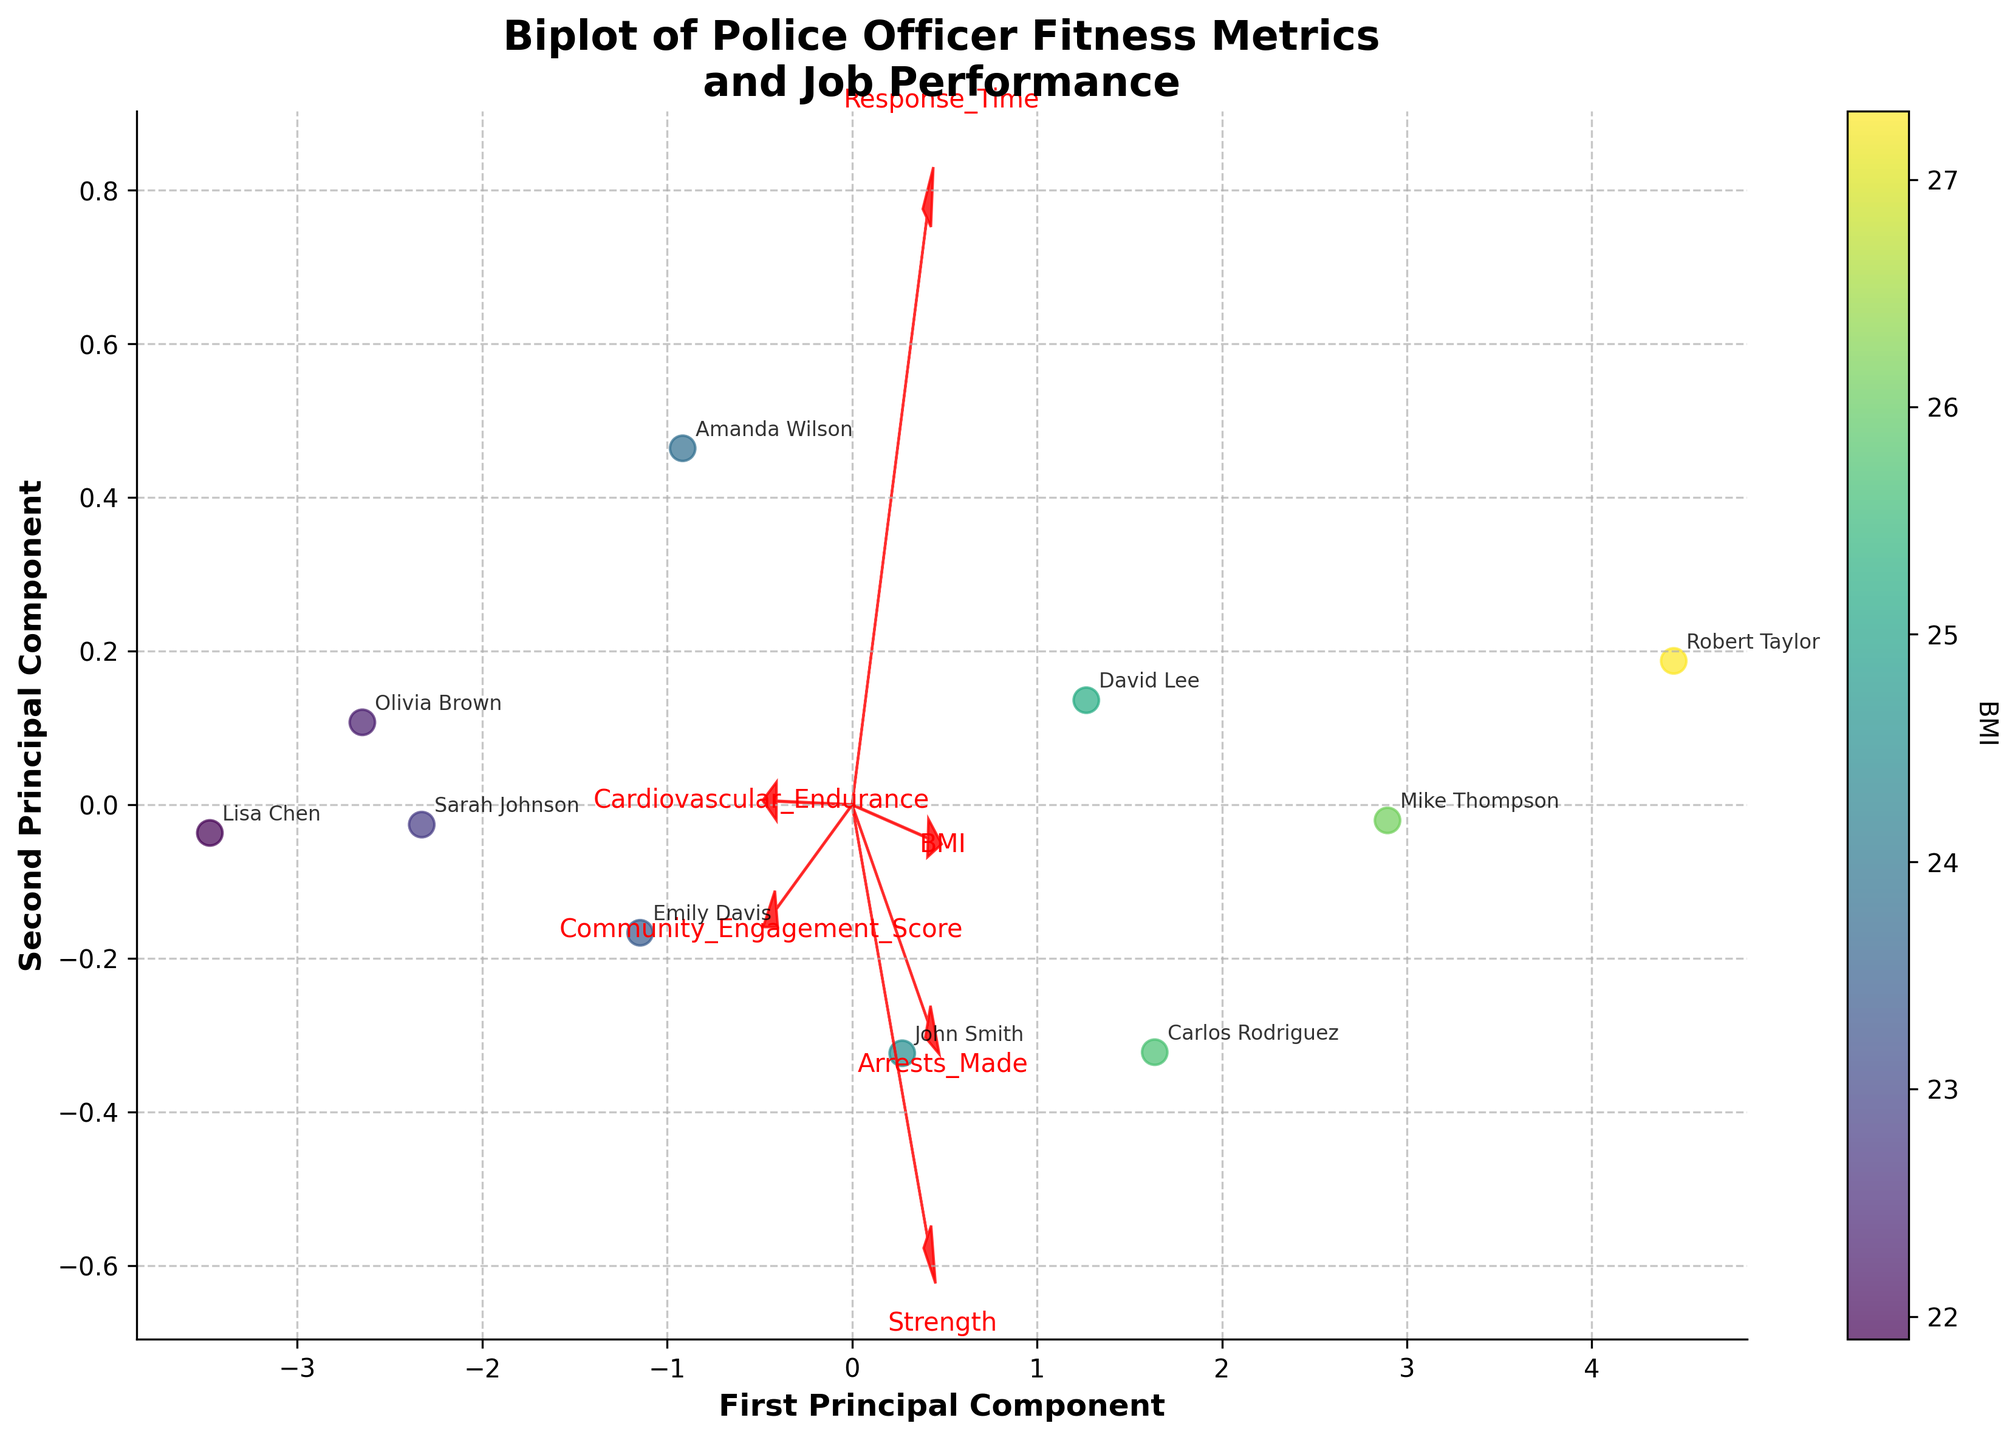What's the title of the biplot? Look at the top of the biplot where the title is usually placed.
Answer: Biplot of Police Officer Fitness Metrics and Job Performance How many principal components are plotted? The number of principal components is indicated by the x-axis and y-axis labels.
Answer: 2 Which officer is closest to the origin (0,0)? The origin of the graph is at (0,0), the officer closest to this point needs to be identified.
Answer: David Lee Which fitness metric seems to have the strongest influence on the first principal component? The direction and length of the arrow representing a fitness metric can indicate its influence. The longer the arrow in the horizontal (x-axis) direction, the stronger the influence.
Answer: Cardiovascular_Endurance What color range indicates a higher BMI in the colorbar? Look at the colorbar on the side of the plot, which shows the gradient and corresponding BMI values.
Answer: Darker purple Which officer has the highest Community Engagement Score according to the plot? Find the officer whose annotation is closest to the vector representing Community_Engagement_Score.
Answer: Lisa Chen Are the variables 'Arrests_Made' and 'Response_Time' positively correlated? Examine the directions of the arrows representing these two variables. If they point in similar directions, the variables are positively correlated.
Answer: Yes Which two officers have similar scores on the second principal component? Identify the officers whose positions are closest in the vertical direction (y-axis).
Answer: Sarah Johnson and Olivia Brown Which fitness metric is most positively correlated with 'Strength'? The arrow directions can indicate correlations; the metric whose arrow points in a similar direction to 'Strength' is most positively correlated.
Answer: Arrests_Made How does 'Community_Engagement_Score' relate to the first principal component compared to 'BMI'? Compare the directions and lengths of the vectors for 'Community_Engagement_Score' and 'BMI' on the biplot.
Answer: Community_Engagement_Score has a stronger positive relation to the first principal component compared to BMI 